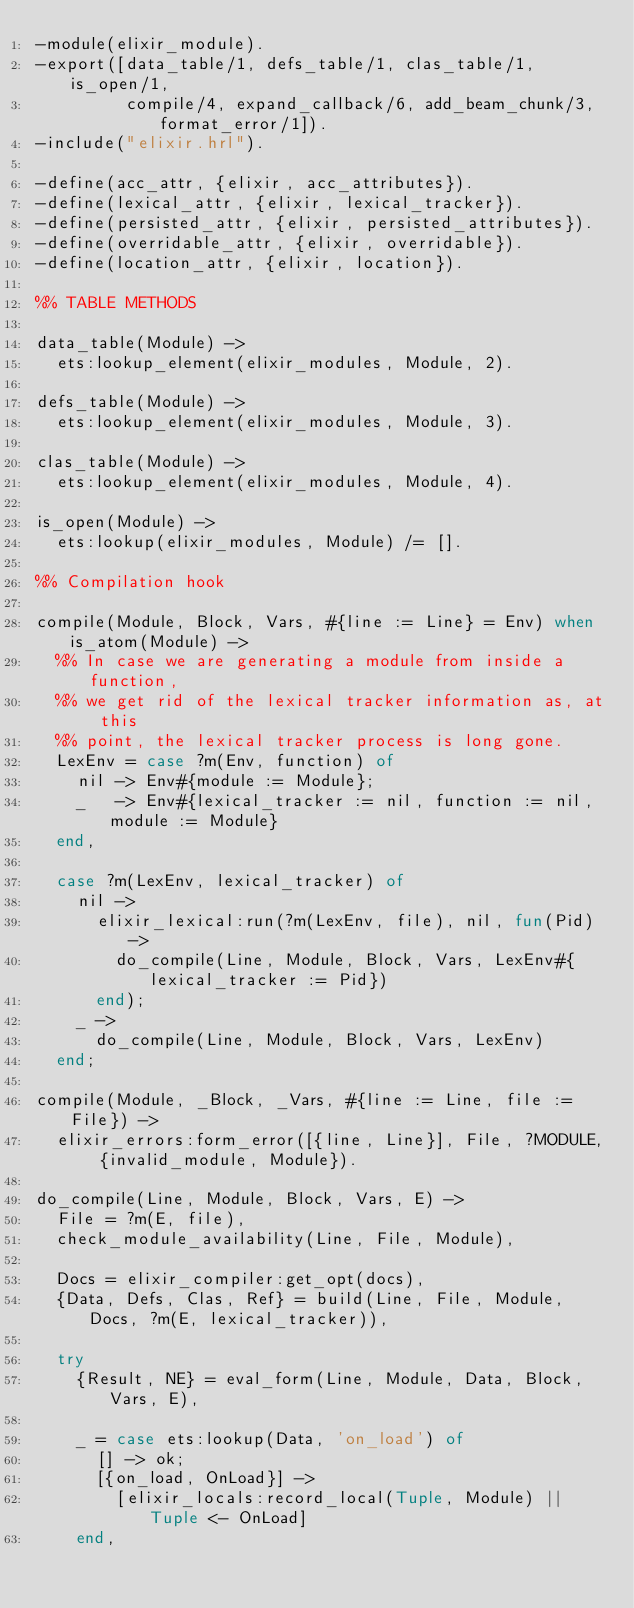Convert code to text. <code><loc_0><loc_0><loc_500><loc_500><_Erlang_>-module(elixir_module).
-export([data_table/1, defs_table/1, clas_table/1, is_open/1,
         compile/4, expand_callback/6, add_beam_chunk/3, format_error/1]).
-include("elixir.hrl").

-define(acc_attr, {elixir, acc_attributes}).
-define(lexical_attr, {elixir, lexical_tracker}).
-define(persisted_attr, {elixir, persisted_attributes}).
-define(overridable_attr, {elixir, overridable}).
-define(location_attr, {elixir, location}).

%% TABLE METHODS

data_table(Module) ->
  ets:lookup_element(elixir_modules, Module, 2).

defs_table(Module) ->
  ets:lookup_element(elixir_modules, Module, 3).

clas_table(Module) ->
  ets:lookup_element(elixir_modules, Module, 4).

is_open(Module) ->
  ets:lookup(elixir_modules, Module) /= [].

%% Compilation hook

compile(Module, Block, Vars, #{line := Line} = Env) when is_atom(Module) ->
  %% In case we are generating a module from inside a function,
  %% we get rid of the lexical tracker information as, at this
  %% point, the lexical tracker process is long gone.
  LexEnv = case ?m(Env, function) of
    nil -> Env#{module := Module};
    _   -> Env#{lexical_tracker := nil, function := nil, module := Module}
  end,

  case ?m(LexEnv, lexical_tracker) of
    nil ->
      elixir_lexical:run(?m(LexEnv, file), nil, fun(Pid) ->
        do_compile(Line, Module, Block, Vars, LexEnv#{lexical_tracker := Pid})
      end);
    _ ->
      do_compile(Line, Module, Block, Vars, LexEnv)
  end;

compile(Module, _Block, _Vars, #{line := Line, file := File}) ->
  elixir_errors:form_error([{line, Line}], File, ?MODULE, {invalid_module, Module}).

do_compile(Line, Module, Block, Vars, E) ->
  File = ?m(E, file),
  check_module_availability(Line, File, Module),

  Docs = elixir_compiler:get_opt(docs),
  {Data, Defs, Clas, Ref} = build(Line, File, Module, Docs, ?m(E, lexical_tracker)),

  try
    {Result, NE} = eval_form(Line, Module, Data, Block, Vars, E),

    _ = case ets:lookup(Data, 'on_load') of
      [] -> ok;
      [{on_load, OnLoad}] ->
        [elixir_locals:record_local(Tuple, Module) || Tuple <- OnLoad]
    end,
</code> 